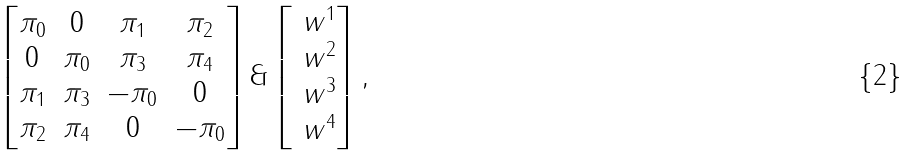<formula> <loc_0><loc_0><loc_500><loc_500>\begin{bmatrix} \pi _ { 0 } & 0 & \pi _ { 1 } & \pi _ { 2 } \\ 0 & \pi _ { 0 } & \pi _ { 3 } & \pi _ { 4 } \\ \pi _ { 1 } & \pi _ { 3 } & - \pi _ { 0 } & 0 \\ \pi _ { 2 } & \pi _ { 4 } & 0 & - \pi _ { 0 } \end{bmatrix} \& \begin{bmatrix} \ w ^ { 1 } \\ \ w ^ { 2 } \\ \ w ^ { 3 } \\ \ w ^ { 4 } \end{bmatrix} ,</formula> 